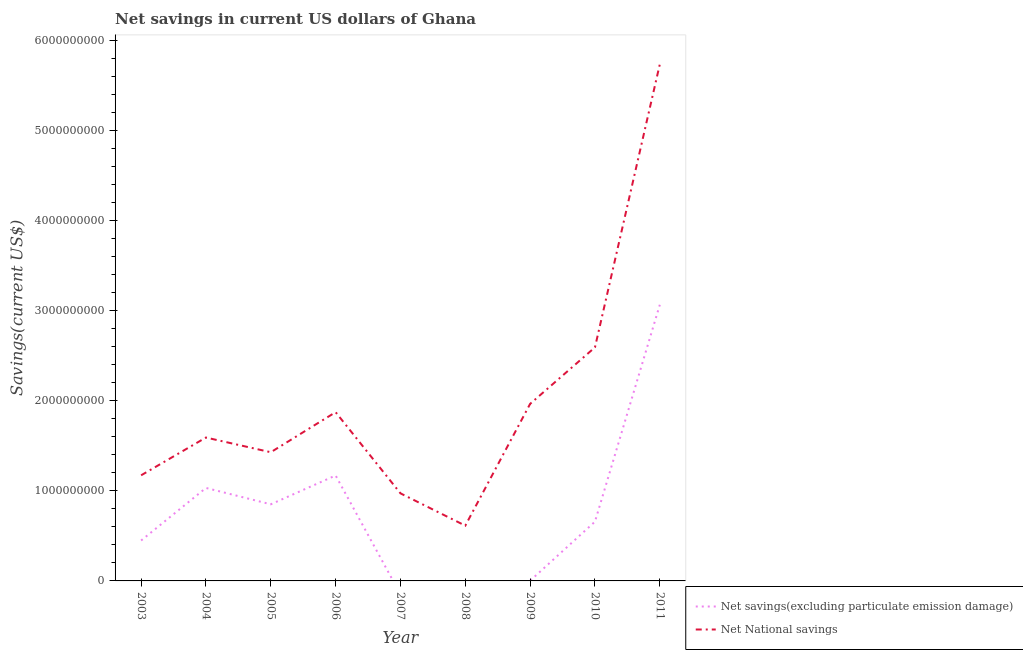Is the number of lines equal to the number of legend labels?
Ensure brevity in your answer.  No. What is the net national savings in 2003?
Offer a very short reply. 1.17e+09. Across all years, what is the maximum net savings(excluding particulate emission damage)?
Ensure brevity in your answer.  3.06e+09. Across all years, what is the minimum net national savings?
Offer a terse response. 6.13e+08. In which year was the net savings(excluding particulate emission damage) maximum?
Your response must be concise. 2011. What is the total net national savings in the graph?
Make the answer very short. 1.79e+1. What is the difference between the net national savings in 2003 and that in 2004?
Offer a very short reply. -4.19e+08. What is the difference between the net savings(excluding particulate emission damage) in 2011 and the net national savings in 2005?
Offer a very short reply. 1.64e+09. What is the average net savings(excluding particulate emission damage) per year?
Provide a short and direct response. 8.03e+08. In the year 2006, what is the difference between the net national savings and net savings(excluding particulate emission damage)?
Make the answer very short. 7.02e+08. In how many years, is the net national savings greater than 4600000000 US$?
Your response must be concise. 1. What is the ratio of the net savings(excluding particulate emission damage) in 2005 to that in 2006?
Your answer should be compact. 0.73. Is the net national savings in 2004 less than that in 2010?
Ensure brevity in your answer.  Yes. Is the difference between the net savings(excluding particulate emission damage) in 2003 and 2005 greater than the difference between the net national savings in 2003 and 2005?
Provide a succinct answer. No. What is the difference between the highest and the second highest net national savings?
Keep it short and to the point. 3.14e+09. What is the difference between the highest and the lowest net national savings?
Keep it short and to the point. 5.12e+09. Is the sum of the net savings(excluding particulate emission damage) in 2005 and 2009 greater than the maximum net national savings across all years?
Give a very brief answer. No. How many lines are there?
Make the answer very short. 2. How many years are there in the graph?
Your response must be concise. 9. What is the difference between two consecutive major ticks on the Y-axis?
Provide a succinct answer. 1.00e+09. Are the values on the major ticks of Y-axis written in scientific E-notation?
Your response must be concise. No. Does the graph contain grids?
Ensure brevity in your answer.  No. Where does the legend appear in the graph?
Your response must be concise. Bottom right. How many legend labels are there?
Offer a terse response. 2. What is the title of the graph?
Give a very brief answer. Net savings in current US dollars of Ghana. Does "Arms exports" appear as one of the legend labels in the graph?
Offer a terse response. No. What is the label or title of the Y-axis?
Provide a short and direct response. Savings(current US$). What is the Savings(current US$) in Net savings(excluding particulate emission damage) in 2003?
Ensure brevity in your answer.  4.48e+08. What is the Savings(current US$) in Net National savings in 2003?
Your response must be concise. 1.17e+09. What is the Savings(current US$) of Net savings(excluding particulate emission damage) in 2004?
Keep it short and to the point. 1.03e+09. What is the Savings(current US$) of Net National savings in 2004?
Your answer should be very brief. 1.59e+09. What is the Savings(current US$) in Net savings(excluding particulate emission damage) in 2005?
Offer a terse response. 8.50e+08. What is the Savings(current US$) of Net National savings in 2005?
Your response must be concise. 1.43e+09. What is the Savings(current US$) in Net savings(excluding particulate emission damage) in 2006?
Offer a very short reply. 1.17e+09. What is the Savings(current US$) in Net National savings in 2006?
Your answer should be very brief. 1.87e+09. What is the Savings(current US$) in Net National savings in 2007?
Your response must be concise. 9.72e+08. What is the Savings(current US$) in Net savings(excluding particulate emission damage) in 2008?
Keep it short and to the point. 0. What is the Savings(current US$) in Net National savings in 2008?
Offer a terse response. 6.13e+08. What is the Savings(current US$) of Net savings(excluding particulate emission damage) in 2009?
Give a very brief answer. 2.35e+06. What is the Savings(current US$) in Net National savings in 2009?
Your response must be concise. 1.96e+09. What is the Savings(current US$) in Net savings(excluding particulate emission damage) in 2010?
Provide a succinct answer. 6.58e+08. What is the Savings(current US$) of Net National savings in 2010?
Provide a succinct answer. 2.59e+09. What is the Savings(current US$) of Net savings(excluding particulate emission damage) in 2011?
Your answer should be very brief. 3.06e+09. What is the Savings(current US$) of Net National savings in 2011?
Give a very brief answer. 5.73e+09. Across all years, what is the maximum Savings(current US$) in Net savings(excluding particulate emission damage)?
Ensure brevity in your answer.  3.06e+09. Across all years, what is the maximum Savings(current US$) in Net National savings?
Keep it short and to the point. 5.73e+09. Across all years, what is the minimum Savings(current US$) of Net savings(excluding particulate emission damage)?
Offer a terse response. 0. Across all years, what is the minimum Savings(current US$) in Net National savings?
Keep it short and to the point. 6.13e+08. What is the total Savings(current US$) of Net savings(excluding particulate emission damage) in the graph?
Provide a succinct answer. 7.22e+09. What is the total Savings(current US$) of Net National savings in the graph?
Your response must be concise. 1.79e+1. What is the difference between the Savings(current US$) of Net savings(excluding particulate emission damage) in 2003 and that in 2004?
Your response must be concise. -5.83e+08. What is the difference between the Savings(current US$) of Net National savings in 2003 and that in 2004?
Make the answer very short. -4.19e+08. What is the difference between the Savings(current US$) in Net savings(excluding particulate emission damage) in 2003 and that in 2005?
Give a very brief answer. -4.02e+08. What is the difference between the Savings(current US$) in Net National savings in 2003 and that in 2005?
Ensure brevity in your answer.  -2.56e+08. What is the difference between the Savings(current US$) in Net savings(excluding particulate emission damage) in 2003 and that in 2006?
Offer a terse response. -7.21e+08. What is the difference between the Savings(current US$) in Net National savings in 2003 and that in 2006?
Your response must be concise. -7.00e+08. What is the difference between the Savings(current US$) of Net National savings in 2003 and that in 2007?
Offer a very short reply. 2.00e+08. What is the difference between the Savings(current US$) in Net National savings in 2003 and that in 2008?
Keep it short and to the point. 5.59e+08. What is the difference between the Savings(current US$) in Net savings(excluding particulate emission damage) in 2003 and that in 2009?
Provide a short and direct response. 4.46e+08. What is the difference between the Savings(current US$) in Net National savings in 2003 and that in 2009?
Provide a short and direct response. -7.93e+08. What is the difference between the Savings(current US$) in Net savings(excluding particulate emission damage) in 2003 and that in 2010?
Keep it short and to the point. -2.09e+08. What is the difference between the Savings(current US$) of Net National savings in 2003 and that in 2010?
Your answer should be very brief. -1.42e+09. What is the difference between the Savings(current US$) in Net savings(excluding particulate emission damage) in 2003 and that in 2011?
Provide a short and direct response. -2.61e+09. What is the difference between the Savings(current US$) in Net National savings in 2003 and that in 2011?
Provide a short and direct response. -4.56e+09. What is the difference between the Savings(current US$) in Net savings(excluding particulate emission damage) in 2004 and that in 2005?
Give a very brief answer. 1.82e+08. What is the difference between the Savings(current US$) of Net National savings in 2004 and that in 2005?
Your answer should be compact. 1.63e+08. What is the difference between the Savings(current US$) of Net savings(excluding particulate emission damage) in 2004 and that in 2006?
Your answer should be compact. -1.38e+08. What is the difference between the Savings(current US$) in Net National savings in 2004 and that in 2006?
Make the answer very short. -2.81e+08. What is the difference between the Savings(current US$) in Net National savings in 2004 and that in 2007?
Your answer should be very brief. 6.19e+08. What is the difference between the Savings(current US$) in Net National savings in 2004 and that in 2008?
Provide a short and direct response. 9.78e+08. What is the difference between the Savings(current US$) in Net savings(excluding particulate emission damage) in 2004 and that in 2009?
Your response must be concise. 1.03e+09. What is the difference between the Savings(current US$) of Net National savings in 2004 and that in 2009?
Give a very brief answer. -3.74e+08. What is the difference between the Savings(current US$) in Net savings(excluding particulate emission damage) in 2004 and that in 2010?
Your response must be concise. 3.74e+08. What is the difference between the Savings(current US$) of Net National savings in 2004 and that in 2010?
Provide a short and direct response. -1.00e+09. What is the difference between the Savings(current US$) of Net savings(excluding particulate emission damage) in 2004 and that in 2011?
Your response must be concise. -2.03e+09. What is the difference between the Savings(current US$) in Net National savings in 2004 and that in 2011?
Provide a short and direct response. -4.14e+09. What is the difference between the Savings(current US$) in Net savings(excluding particulate emission damage) in 2005 and that in 2006?
Offer a very short reply. -3.20e+08. What is the difference between the Savings(current US$) of Net National savings in 2005 and that in 2006?
Give a very brief answer. -4.44e+08. What is the difference between the Savings(current US$) of Net National savings in 2005 and that in 2007?
Your answer should be very brief. 4.56e+08. What is the difference between the Savings(current US$) of Net National savings in 2005 and that in 2008?
Keep it short and to the point. 8.15e+08. What is the difference between the Savings(current US$) of Net savings(excluding particulate emission damage) in 2005 and that in 2009?
Provide a succinct answer. 8.48e+08. What is the difference between the Savings(current US$) in Net National savings in 2005 and that in 2009?
Give a very brief answer. -5.37e+08. What is the difference between the Savings(current US$) of Net savings(excluding particulate emission damage) in 2005 and that in 2010?
Ensure brevity in your answer.  1.92e+08. What is the difference between the Savings(current US$) of Net National savings in 2005 and that in 2010?
Give a very brief answer. -1.16e+09. What is the difference between the Savings(current US$) of Net savings(excluding particulate emission damage) in 2005 and that in 2011?
Provide a short and direct response. -2.21e+09. What is the difference between the Savings(current US$) of Net National savings in 2005 and that in 2011?
Your response must be concise. -4.30e+09. What is the difference between the Savings(current US$) in Net National savings in 2006 and that in 2007?
Your answer should be very brief. 9.01e+08. What is the difference between the Savings(current US$) in Net National savings in 2006 and that in 2008?
Ensure brevity in your answer.  1.26e+09. What is the difference between the Savings(current US$) in Net savings(excluding particulate emission damage) in 2006 and that in 2009?
Give a very brief answer. 1.17e+09. What is the difference between the Savings(current US$) of Net National savings in 2006 and that in 2009?
Your answer should be compact. -9.25e+07. What is the difference between the Savings(current US$) in Net savings(excluding particulate emission damage) in 2006 and that in 2010?
Offer a terse response. 5.12e+08. What is the difference between the Savings(current US$) in Net National savings in 2006 and that in 2010?
Provide a succinct answer. -7.19e+08. What is the difference between the Savings(current US$) in Net savings(excluding particulate emission damage) in 2006 and that in 2011?
Your answer should be compact. -1.89e+09. What is the difference between the Savings(current US$) in Net National savings in 2006 and that in 2011?
Ensure brevity in your answer.  -3.86e+09. What is the difference between the Savings(current US$) in Net National savings in 2007 and that in 2008?
Your response must be concise. 3.59e+08. What is the difference between the Savings(current US$) of Net National savings in 2007 and that in 2009?
Your answer should be very brief. -9.93e+08. What is the difference between the Savings(current US$) of Net National savings in 2007 and that in 2010?
Keep it short and to the point. -1.62e+09. What is the difference between the Savings(current US$) of Net National savings in 2007 and that in 2011?
Offer a terse response. -4.76e+09. What is the difference between the Savings(current US$) of Net National savings in 2008 and that in 2009?
Ensure brevity in your answer.  -1.35e+09. What is the difference between the Savings(current US$) in Net National savings in 2008 and that in 2010?
Offer a very short reply. -1.98e+09. What is the difference between the Savings(current US$) in Net National savings in 2008 and that in 2011?
Ensure brevity in your answer.  -5.12e+09. What is the difference between the Savings(current US$) of Net savings(excluding particulate emission damage) in 2009 and that in 2010?
Ensure brevity in your answer.  -6.55e+08. What is the difference between the Savings(current US$) of Net National savings in 2009 and that in 2010?
Ensure brevity in your answer.  -6.27e+08. What is the difference between the Savings(current US$) of Net savings(excluding particulate emission damage) in 2009 and that in 2011?
Your response must be concise. -3.06e+09. What is the difference between the Savings(current US$) in Net National savings in 2009 and that in 2011?
Offer a terse response. -3.77e+09. What is the difference between the Savings(current US$) in Net savings(excluding particulate emission damage) in 2010 and that in 2011?
Provide a short and direct response. -2.41e+09. What is the difference between the Savings(current US$) in Net National savings in 2010 and that in 2011?
Give a very brief answer. -3.14e+09. What is the difference between the Savings(current US$) in Net savings(excluding particulate emission damage) in 2003 and the Savings(current US$) in Net National savings in 2004?
Your response must be concise. -1.14e+09. What is the difference between the Savings(current US$) in Net savings(excluding particulate emission damage) in 2003 and the Savings(current US$) in Net National savings in 2005?
Your response must be concise. -9.79e+08. What is the difference between the Savings(current US$) of Net savings(excluding particulate emission damage) in 2003 and the Savings(current US$) of Net National savings in 2006?
Ensure brevity in your answer.  -1.42e+09. What is the difference between the Savings(current US$) of Net savings(excluding particulate emission damage) in 2003 and the Savings(current US$) of Net National savings in 2007?
Your response must be concise. -5.23e+08. What is the difference between the Savings(current US$) in Net savings(excluding particulate emission damage) in 2003 and the Savings(current US$) in Net National savings in 2008?
Offer a terse response. -1.65e+08. What is the difference between the Savings(current US$) of Net savings(excluding particulate emission damage) in 2003 and the Savings(current US$) of Net National savings in 2009?
Give a very brief answer. -1.52e+09. What is the difference between the Savings(current US$) of Net savings(excluding particulate emission damage) in 2003 and the Savings(current US$) of Net National savings in 2010?
Make the answer very short. -2.14e+09. What is the difference between the Savings(current US$) of Net savings(excluding particulate emission damage) in 2003 and the Savings(current US$) of Net National savings in 2011?
Offer a very short reply. -5.28e+09. What is the difference between the Savings(current US$) of Net savings(excluding particulate emission damage) in 2004 and the Savings(current US$) of Net National savings in 2005?
Ensure brevity in your answer.  -3.96e+08. What is the difference between the Savings(current US$) of Net savings(excluding particulate emission damage) in 2004 and the Savings(current US$) of Net National savings in 2006?
Provide a short and direct response. -8.40e+08. What is the difference between the Savings(current US$) of Net savings(excluding particulate emission damage) in 2004 and the Savings(current US$) of Net National savings in 2007?
Give a very brief answer. 6.02e+07. What is the difference between the Savings(current US$) in Net savings(excluding particulate emission damage) in 2004 and the Savings(current US$) in Net National savings in 2008?
Provide a succinct answer. 4.19e+08. What is the difference between the Savings(current US$) of Net savings(excluding particulate emission damage) in 2004 and the Savings(current US$) of Net National savings in 2009?
Your answer should be very brief. -9.33e+08. What is the difference between the Savings(current US$) in Net savings(excluding particulate emission damage) in 2004 and the Savings(current US$) in Net National savings in 2010?
Provide a succinct answer. -1.56e+09. What is the difference between the Savings(current US$) of Net savings(excluding particulate emission damage) in 2004 and the Savings(current US$) of Net National savings in 2011?
Make the answer very short. -4.70e+09. What is the difference between the Savings(current US$) in Net savings(excluding particulate emission damage) in 2005 and the Savings(current US$) in Net National savings in 2006?
Your answer should be compact. -1.02e+09. What is the difference between the Savings(current US$) of Net savings(excluding particulate emission damage) in 2005 and the Savings(current US$) of Net National savings in 2007?
Give a very brief answer. -1.22e+08. What is the difference between the Savings(current US$) of Net savings(excluding particulate emission damage) in 2005 and the Savings(current US$) of Net National savings in 2008?
Ensure brevity in your answer.  2.37e+08. What is the difference between the Savings(current US$) of Net savings(excluding particulate emission damage) in 2005 and the Savings(current US$) of Net National savings in 2009?
Offer a very short reply. -1.11e+09. What is the difference between the Savings(current US$) in Net savings(excluding particulate emission damage) in 2005 and the Savings(current US$) in Net National savings in 2010?
Provide a short and direct response. -1.74e+09. What is the difference between the Savings(current US$) in Net savings(excluding particulate emission damage) in 2005 and the Savings(current US$) in Net National savings in 2011?
Make the answer very short. -4.88e+09. What is the difference between the Savings(current US$) in Net savings(excluding particulate emission damage) in 2006 and the Savings(current US$) in Net National savings in 2007?
Provide a succinct answer. 1.98e+08. What is the difference between the Savings(current US$) of Net savings(excluding particulate emission damage) in 2006 and the Savings(current US$) of Net National savings in 2008?
Provide a succinct answer. 5.57e+08. What is the difference between the Savings(current US$) in Net savings(excluding particulate emission damage) in 2006 and the Savings(current US$) in Net National savings in 2009?
Make the answer very short. -7.95e+08. What is the difference between the Savings(current US$) in Net savings(excluding particulate emission damage) in 2006 and the Savings(current US$) in Net National savings in 2010?
Give a very brief answer. -1.42e+09. What is the difference between the Savings(current US$) in Net savings(excluding particulate emission damage) in 2006 and the Savings(current US$) in Net National savings in 2011?
Provide a short and direct response. -4.56e+09. What is the difference between the Savings(current US$) of Net savings(excluding particulate emission damage) in 2009 and the Savings(current US$) of Net National savings in 2010?
Offer a very short reply. -2.59e+09. What is the difference between the Savings(current US$) in Net savings(excluding particulate emission damage) in 2009 and the Savings(current US$) in Net National savings in 2011?
Keep it short and to the point. -5.73e+09. What is the difference between the Savings(current US$) of Net savings(excluding particulate emission damage) in 2010 and the Savings(current US$) of Net National savings in 2011?
Your response must be concise. -5.07e+09. What is the average Savings(current US$) in Net savings(excluding particulate emission damage) per year?
Provide a succinct answer. 8.03e+08. What is the average Savings(current US$) in Net National savings per year?
Make the answer very short. 1.99e+09. In the year 2003, what is the difference between the Savings(current US$) of Net savings(excluding particulate emission damage) and Savings(current US$) of Net National savings?
Keep it short and to the point. -7.23e+08. In the year 2004, what is the difference between the Savings(current US$) in Net savings(excluding particulate emission damage) and Savings(current US$) in Net National savings?
Provide a succinct answer. -5.59e+08. In the year 2005, what is the difference between the Savings(current US$) in Net savings(excluding particulate emission damage) and Savings(current US$) in Net National savings?
Provide a succinct answer. -5.78e+08. In the year 2006, what is the difference between the Savings(current US$) in Net savings(excluding particulate emission damage) and Savings(current US$) in Net National savings?
Keep it short and to the point. -7.02e+08. In the year 2009, what is the difference between the Savings(current US$) of Net savings(excluding particulate emission damage) and Savings(current US$) of Net National savings?
Make the answer very short. -1.96e+09. In the year 2010, what is the difference between the Savings(current US$) in Net savings(excluding particulate emission damage) and Savings(current US$) in Net National savings?
Give a very brief answer. -1.93e+09. In the year 2011, what is the difference between the Savings(current US$) of Net savings(excluding particulate emission damage) and Savings(current US$) of Net National savings?
Offer a very short reply. -2.67e+09. What is the ratio of the Savings(current US$) in Net savings(excluding particulate emission damage) in 2003 to that in 2004?
Offer a terse response. 0.43. What is the ratio of the Savings(current US$) in Net National savings in 2003 to that in 2004?
Keep it short and to the point. 0.74. What is the ratio of the Savings(current US$) in Net savings(excluding particulate emission damage) in 2003 to that in 2005?
Your response must be concise. 0.53. What is the ratio of the Savings(current US$) in Net National savings in 2003 to that in 2005?
Offer a terse response. 0.82. What is the ratio of the Savings(current US$) of Net savings(excluding particulate emission damage) in 2003 to that in 2006?
Offer a terse response. 0.38. What is the ratio of the Savings(current US$) of Net National savings in 2003 to that in 2006?
Provide a short and direct response. 0.63. What is the ratio of the Savings(current US$) of Net National savings in 2003 to that in 2007?
Offer a terse response. 1.21. What is the ratio of the Savings(current US$) of Net National savings in 2003 to that in 2008?
Offer a very short reply. 1.91. What is the ratio of the Savings(current US$) of Net savings(excluding particulate emission damage) in 2003 to that in 2009?
Provide a short and direct response. 191.19. What is the ratio of the Savings(current US$) of Net National savings in 2003 to that in 2009?
Ensure brevity in your answer.  0.6. What is the ratio of the Savings(current US$) of Net savings(excluding particulate emission damage) in 2003 to that in 2010?
Provide a succinct answer. 0.68. What is the ratio of the Savings(current US$) of Net National savings in 2003 to that in 2010?
Give a very brief answer. 0.45. What is the ratio of the Savings(current US$) in Net savings(excluding particulate emission damage) in 2003 to that in 2011?
Provide a short and direct response. 0.15. What is the ratio of the Savings(current US$) in Net National savings in 2003 to that in 2011?
Offer a very short reply. 0.2. What is the ratio of the Savings(current US$) in Net savings(excluding particulate emission damage) in 2004 to that in 2005?
Your answer should be compact. 1.21. What is the ratio of the Savings(current US$) of Net National savings in 2004 to that in 2005?
Keep it short and to the point. 1.11. What is the ratio of the Savings(current US$) in Net savings(excluding particulate emission damage) in 2004 to that in 2006?
Provide a short and direct response. 0.88. What is the ratio of the Savings(current US$) of Net National savings in 2004 to that in 2006?
Your answer should be very brief. 0.85. What is the ratio of the Savings(current US$) of Net National savings in 2004 to that in 2007?
Provide a short and direct response. 1.64. What is the ratio of the Savings(current US$) in Net National savings in 2004 to that in 2008?
Give a very brief answer. 2.59. What is the ratio of the Savings(current US$) of Net savings(excluding particulate emission damage) in 2004 to that in 2009?
Your answer should be compact. 439.87. What is the ratio of the Savings(current US$) of Net National savings in 2004 to that in 2009?
Provide a short and direct response. 0.81. What is the ratio of the Savings(current US$) in Net savings(excluding particulate emission damage) in 2004 to that in 2010?
Offer a very short reply. 1.57. What is the ratio of the Savings(current US$) in Net National savings in 2004 to that in 2010?
Provide a short and direct response. 0.61. What is the ratio of the Savings(current US$) of Net savings(excluding particulate emission damage) in 2004 to that in 2011?
Ensure brevity in your answer.  0.34. What is the ratio of the Savings(current US$) of Net National savings in 2004 to that in 2011?
Make the answer very short. 0.28. What is the ratio of the Savings(current US$) of Net savings(excluding particulate emission damage) in 2005 to that in 2006?
Offer a terse response. 0.73. What is the ratio of the Savings(current US$) of Net National savings in 2005 to that in 2006?
Make the answer very short. 0.76. What is the ratio of the Savings(current US$) in Net National savings in 2005 to that in 2007?
Provide a succinct answer. 1.47. What is the ratio of the Savings(current US$) in Net National savings in 2005 to that in 2008?
Ensure brevity in your answer.  2.33. What is the ratio of the Savings(current US$) of Net savings(excluding particulate emission damage) in 2005 to that in 2009?
Ensure brevity in your answer.  362.39. What is the ratio of the Savings(current US$) of Net National savings in 2005 to that in 2009?
Your answer should be very brief. 0.73. What is the ratio of the Savings(current US$) of Net savings(excluding particulate emission damage) in 2005 to that in 2010?
Offer a very short reply. 1.29. What is the ratio of the Savings(current US$) of Net National savings in 2005 to that in 2010?
Provide a succinct answer. 0.55. What is the ratio of the Savings(current US$) in Net savings(excluding particulate emission damage) in 2005 to that in 2011?
Offer a very short reply. 0.28. What is the ratio of the Savings(current US$) in Net National savings in 2005 to that in 2011?
Ensure brevity in your answer.  0.25. What is the ratio of the Savings(current US$) in Net National savings in 2006 to that in 2007?
Give a very brief answer. 1.93. What is the ratio of the Savings(current US$) in Net National savings in 2006 to that in 2008?
Make the answer very short. 3.05. What is the ratio of the Savings(current US$) of Net savings(excluding particulate emission damage) in 2006 to that in 2009?
Provide a short and direct response. 498.74. What is the ratio of the Savings(current US$) of Net National savings in 2006 to that in 2009?
Provide a short and direct response. 0.95. What is the ratio of the Savings(current US$) in Net savings(excluding particulate emission damage) in 2006 to that in 2010?
Your answer should be compact. 1.78. What is the ratio of the Savings(current US$) in Net National savings in 2006 to that in 2010?
Provide a short and direct response. 0.72. What is the ratio of the Savings(current US$) in Net savings(excluding particulate emission damage) in 2006 to that in 2011?
Give a very brief answer. 0.38. What is the ratio of the Savings(current US$) of Net National savings in 2006 to that in 2011?
Your answer should be very brief. 0.33. What is the ratio of the Savings(current US$) of Net National savings in 2007 to that in 2008?
Keep it short and to the point. 1.58. What is the ratio of the Savings(current US$) of Net National savings in 2007 to that in 2009?
Offer a terse response. 0.49. What is the ratio of the Savings(current US$) of Net National savings in 2007 to that in 2010?
Offer a very short reply. 0.37. What is the ratio of the Savings(current US$) in Net National savings in 2007 to that in 2011?
Give a very brief answer. 0.17. What is the ratio of the Savings(current US$) of Net National savings in 2008 to that in 2009?
Provide a short and direct response. 0.31. What is the ratio of the Savings(current US$) in Net National savings in 2008 to that in 2010?
Your answer should be very brief. 0.24. What is the ratio of the Savings(current US$) in Net National savings in 2008 to that in 2011?
Provide a short and direct response. 0.11. What is the ratio of the Savings(current US$) in Net savings(excluding particulate emission damage) in 2009 to that in 2010?
Ensure brevity in your answer.  0. What is the ratio of the Savings(current US$) of Net National savings in 2009 to that in 2010?
Provide a short and direct response. 0.76. What is the ratio of the Savings(current US$) in Net savings(excluding particulate emission damage) in 2009 to that in 2011?
Provide a succinct answer. 0. What is the ratio of the Savings(current US$) in Net National savings in 2009 to that in 2011?
Provide a short and direct response. 0.34. What is the ratio of the Savings(current US$) in Net savings(excluding particulate emission damage) in 2010 to that in 2011?
Offer a terse response. 0.21. What is the ratio of the Savings(current US$) of Net National savings in 2010 to that in 2011?
Provide a short and direct response. 0.45. What is the difference between the highest and the second highest Savings(current US$) of Net savings(excluding particulate emission damage)?
Keep it short and to the point. 1.89e+09. What is the difference between the highest and the second highest Savings(current US$) of Net National savings?
Provide a succinct answer. 3.14e+09. What is the difference between the highest and the lowest Savings(current US$) of Net savings(excluding particulate emission damage)?
Provide a short and direct response. 3.06e+09. What is the difference between the highest and the lowest Savings(current US$) in Net National savings?
Your answer should be compact. 5.12e+09. 